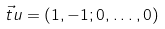Convert formula to latex. <formula><loc_0><loc_0><loc_500><loc_500>\vec { t } { u } = ( 1 , - 1 ; 0 , \dots , 0 )</formula> 